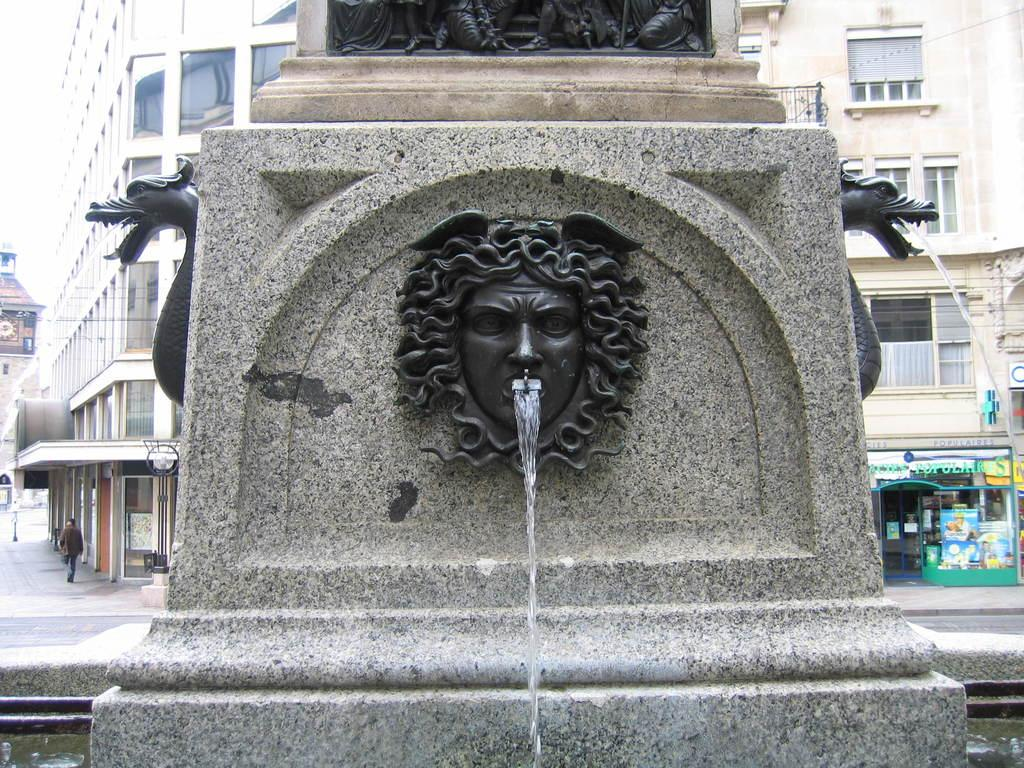What is attached to the wall in the image? There are objects attached to the wall in the image. What is happening with the objects on the wall? Water is flowing down from these objects. What can be seen in the background of the image? There are buildings in the background of the image. Is there a school visible in the image? There is no mention of a school in the provided facts, so we cannot determine if one is visible in the image. Are there any strangers present in the image? There is no mention of strangers in the provided facts, so we cannot determine if any are present in the image. 